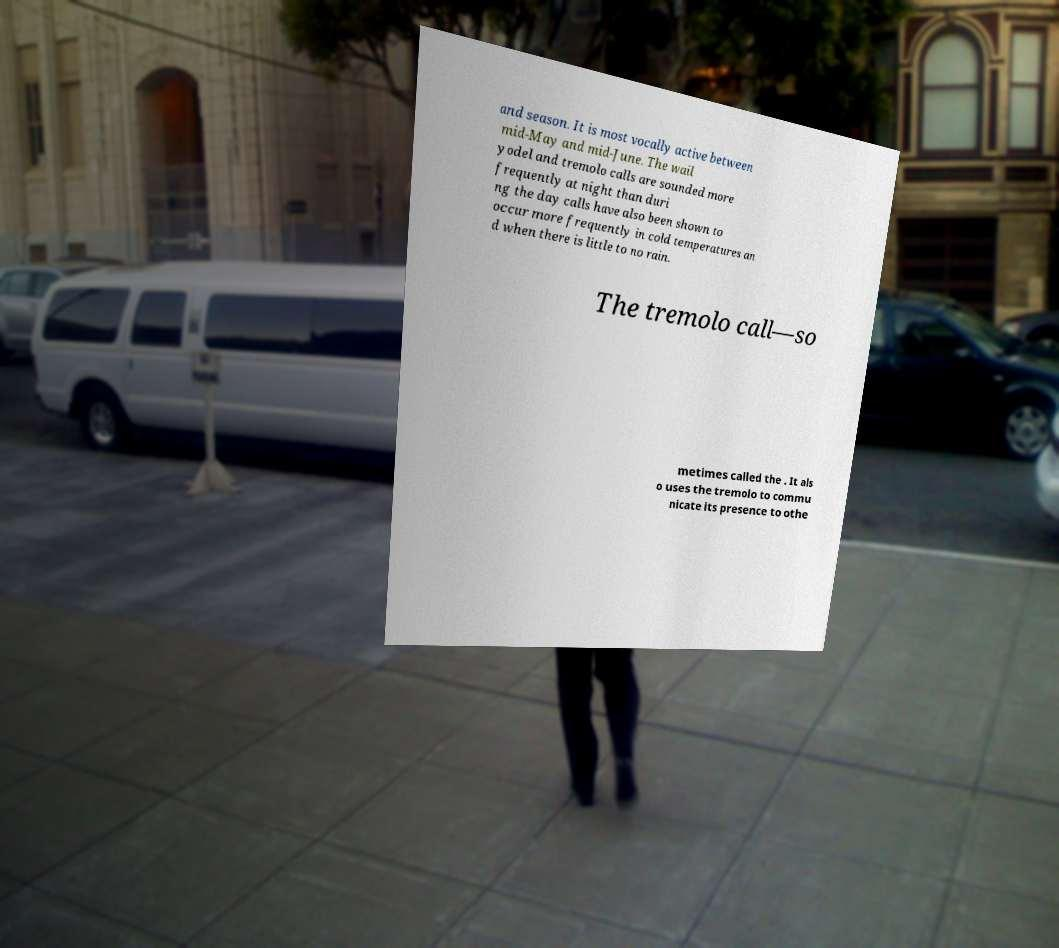Could you extract and type out the text from this image? and season. It is most vocally active between mid-May and mid-June. The wail yodel and tremolo calls are sounded more frequently at night than duri ng the day calls have also been shown to occur more frequently in cold temperatures an d when there is little to no rain. The tremolo call—so metimes called the . It als o uses the tremolo to commu nicate its presence to othe 